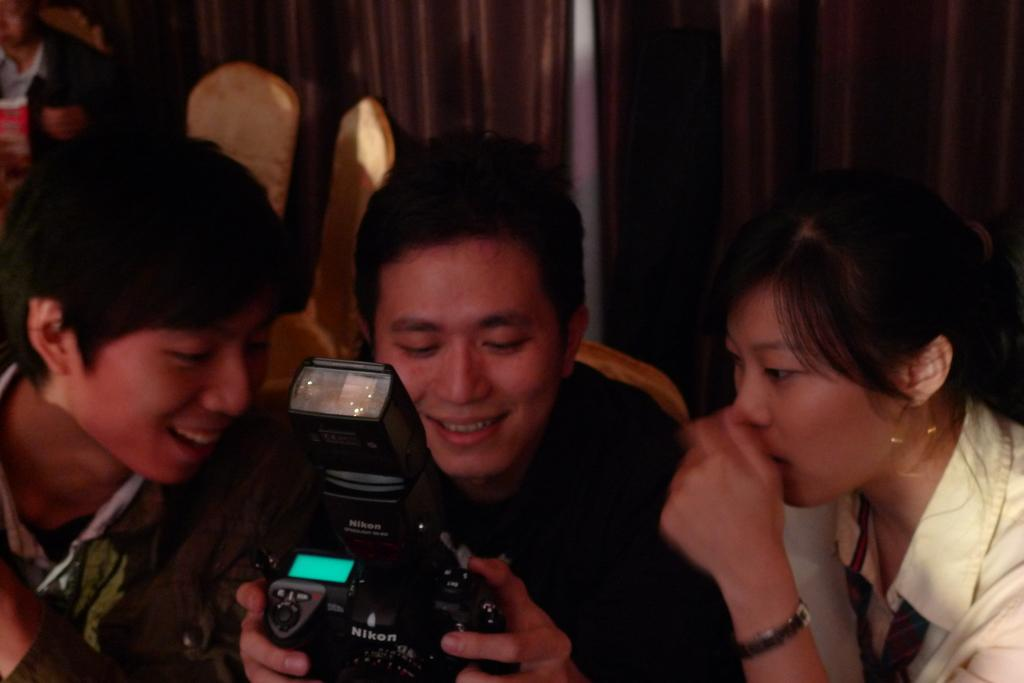Who is the main subject in the image? There is a man in the middle of the image. What is the man holding in the image? The man is holding a camera. What is the man's facial expression in the image? The man is smiling. How many other people are present in the image? There are two persons on either side of the man. What are the two persons doing in the image? The two persons are looking at the camera. What type of plantation can be seen in the background of the image? There is no plantation visible in the image; it features a man holding a camera with two other persons looking at the camera. 